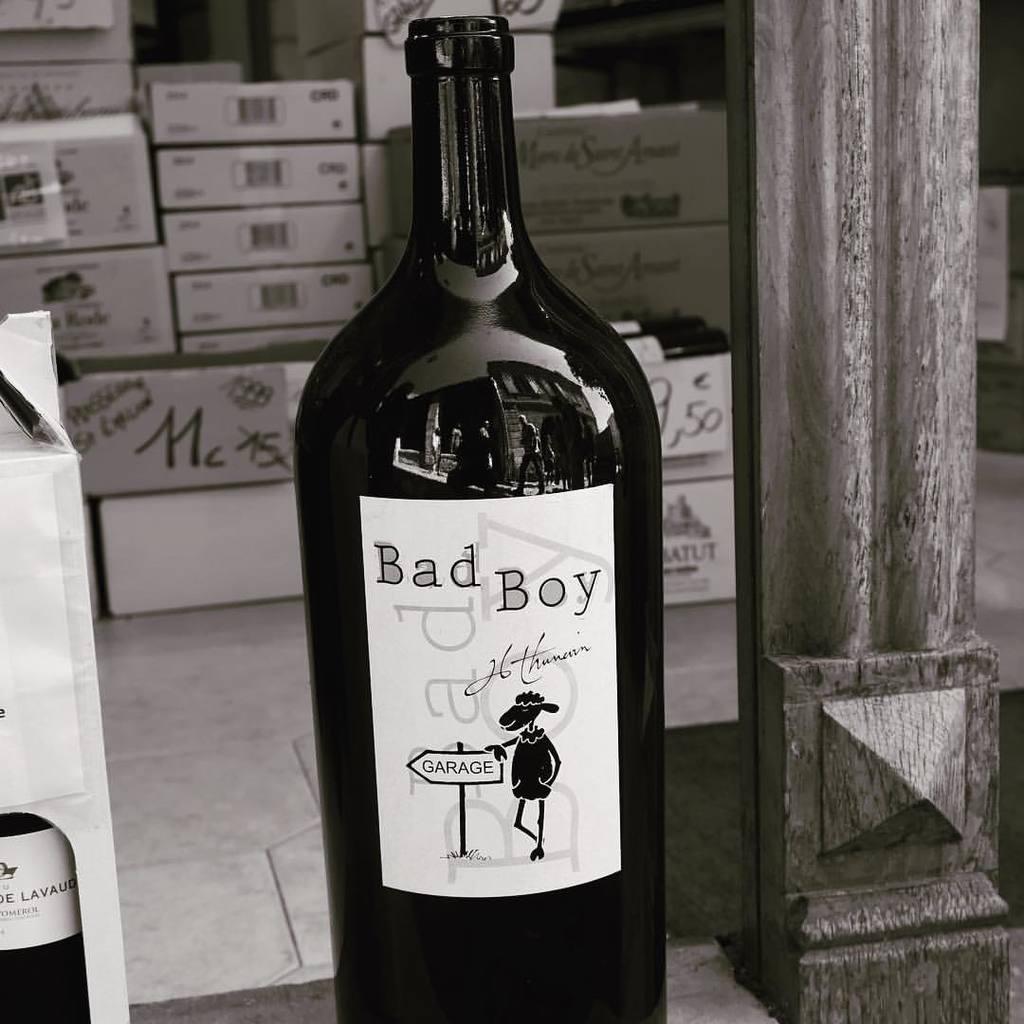Who made this wine?
Keep it short and to the point. Bad boy. 